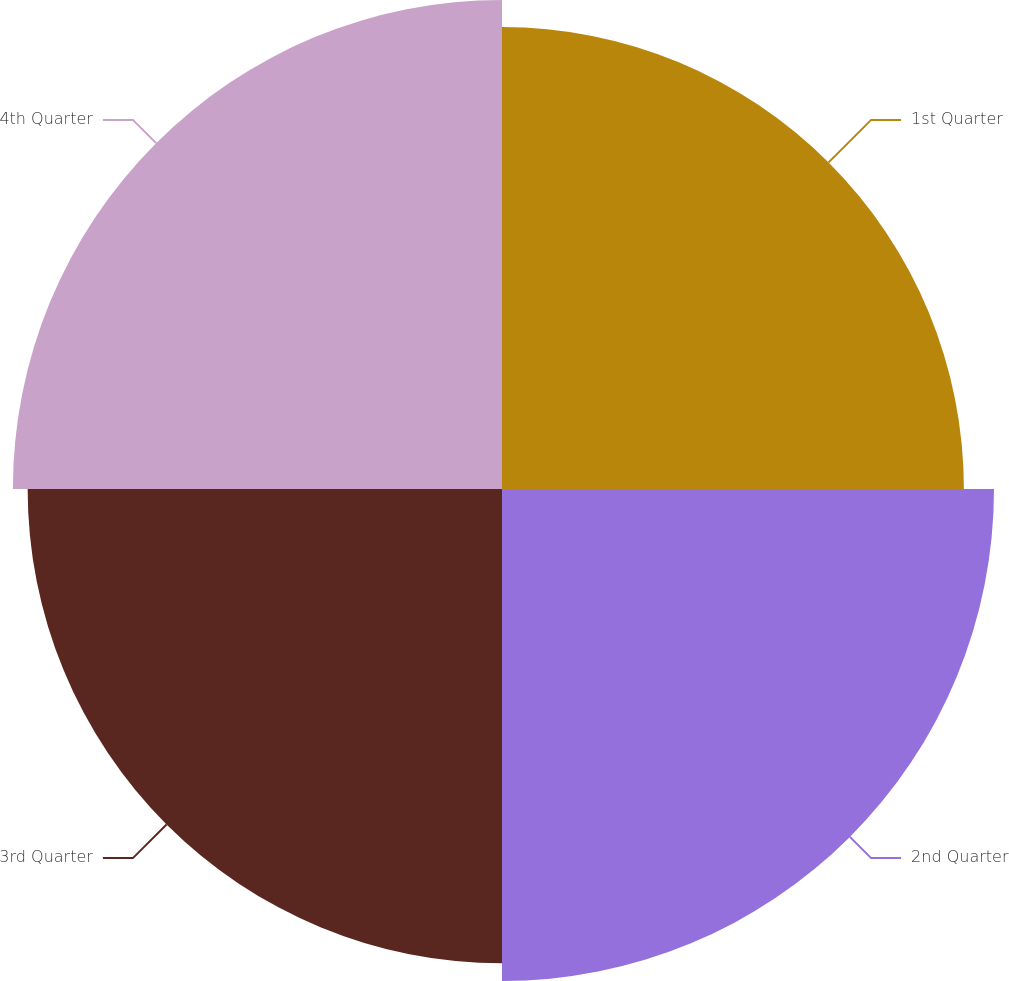<chart> <loc_0><loc_0><loc_500><loc_500><pie_chart><fcel>1st Quarter<fcel>2nd Quarter<fcel>3rd Quarter<fcel>4th Quarter<nl><fcel>24.09%<fcel>25.66%<fcel>24.74%<fcel>25.51%<nl></chart> 